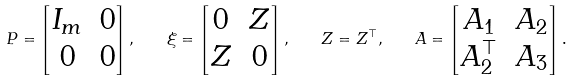<formula> <loc_0><loc_0><loc_500><loc_500>P = \begin{bmatrix} I _ { m } & 0 \\ 0 & 0 \end{bmatrix} , \quad \xi = \begin{bmatrix} 0 & Z \\ Z & 0 \end{bmatrix} , \quad Z = Z ^ { \top } , \quad A = \begin{bmatrix} A _ { 1 } & A _ { 2 } \\ A _ { 2 } ^ { \top } & A _ { 3 } \end{bmatrix} .</formula> 